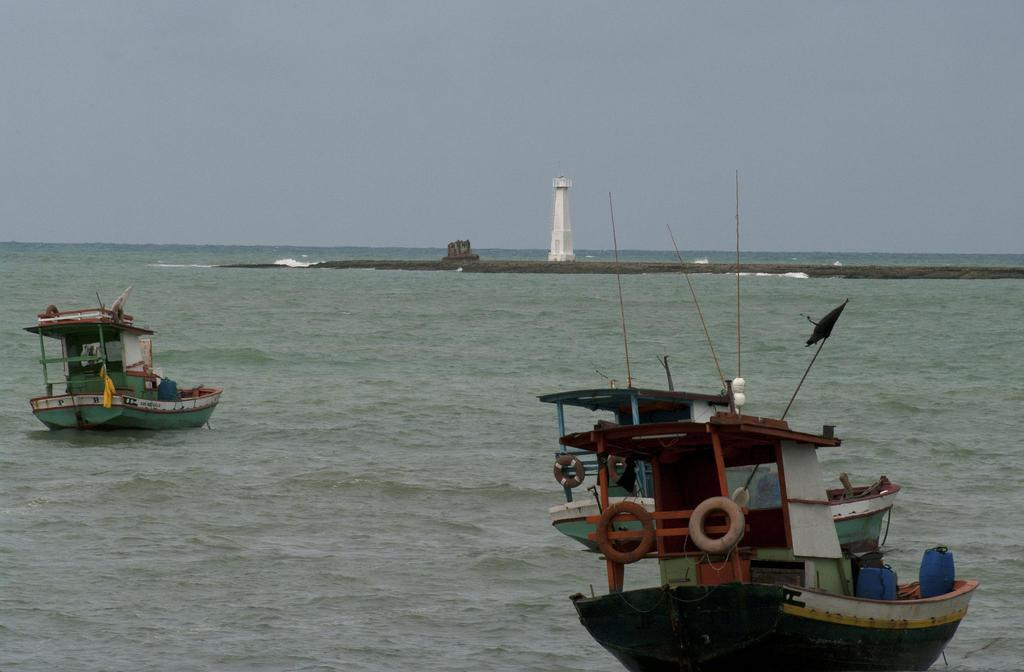What is the main structure in the image? There is a tower in the image. What can be seen on the water in the image? There are boats on water in the image. What is on the boats? There are objects on the boats. What is visible in the background of the image? The sky is visible in the background of the image. What type of pies are being sold at the market in the image? There is no market or pies present in the image; it features a tower and boats on water. 